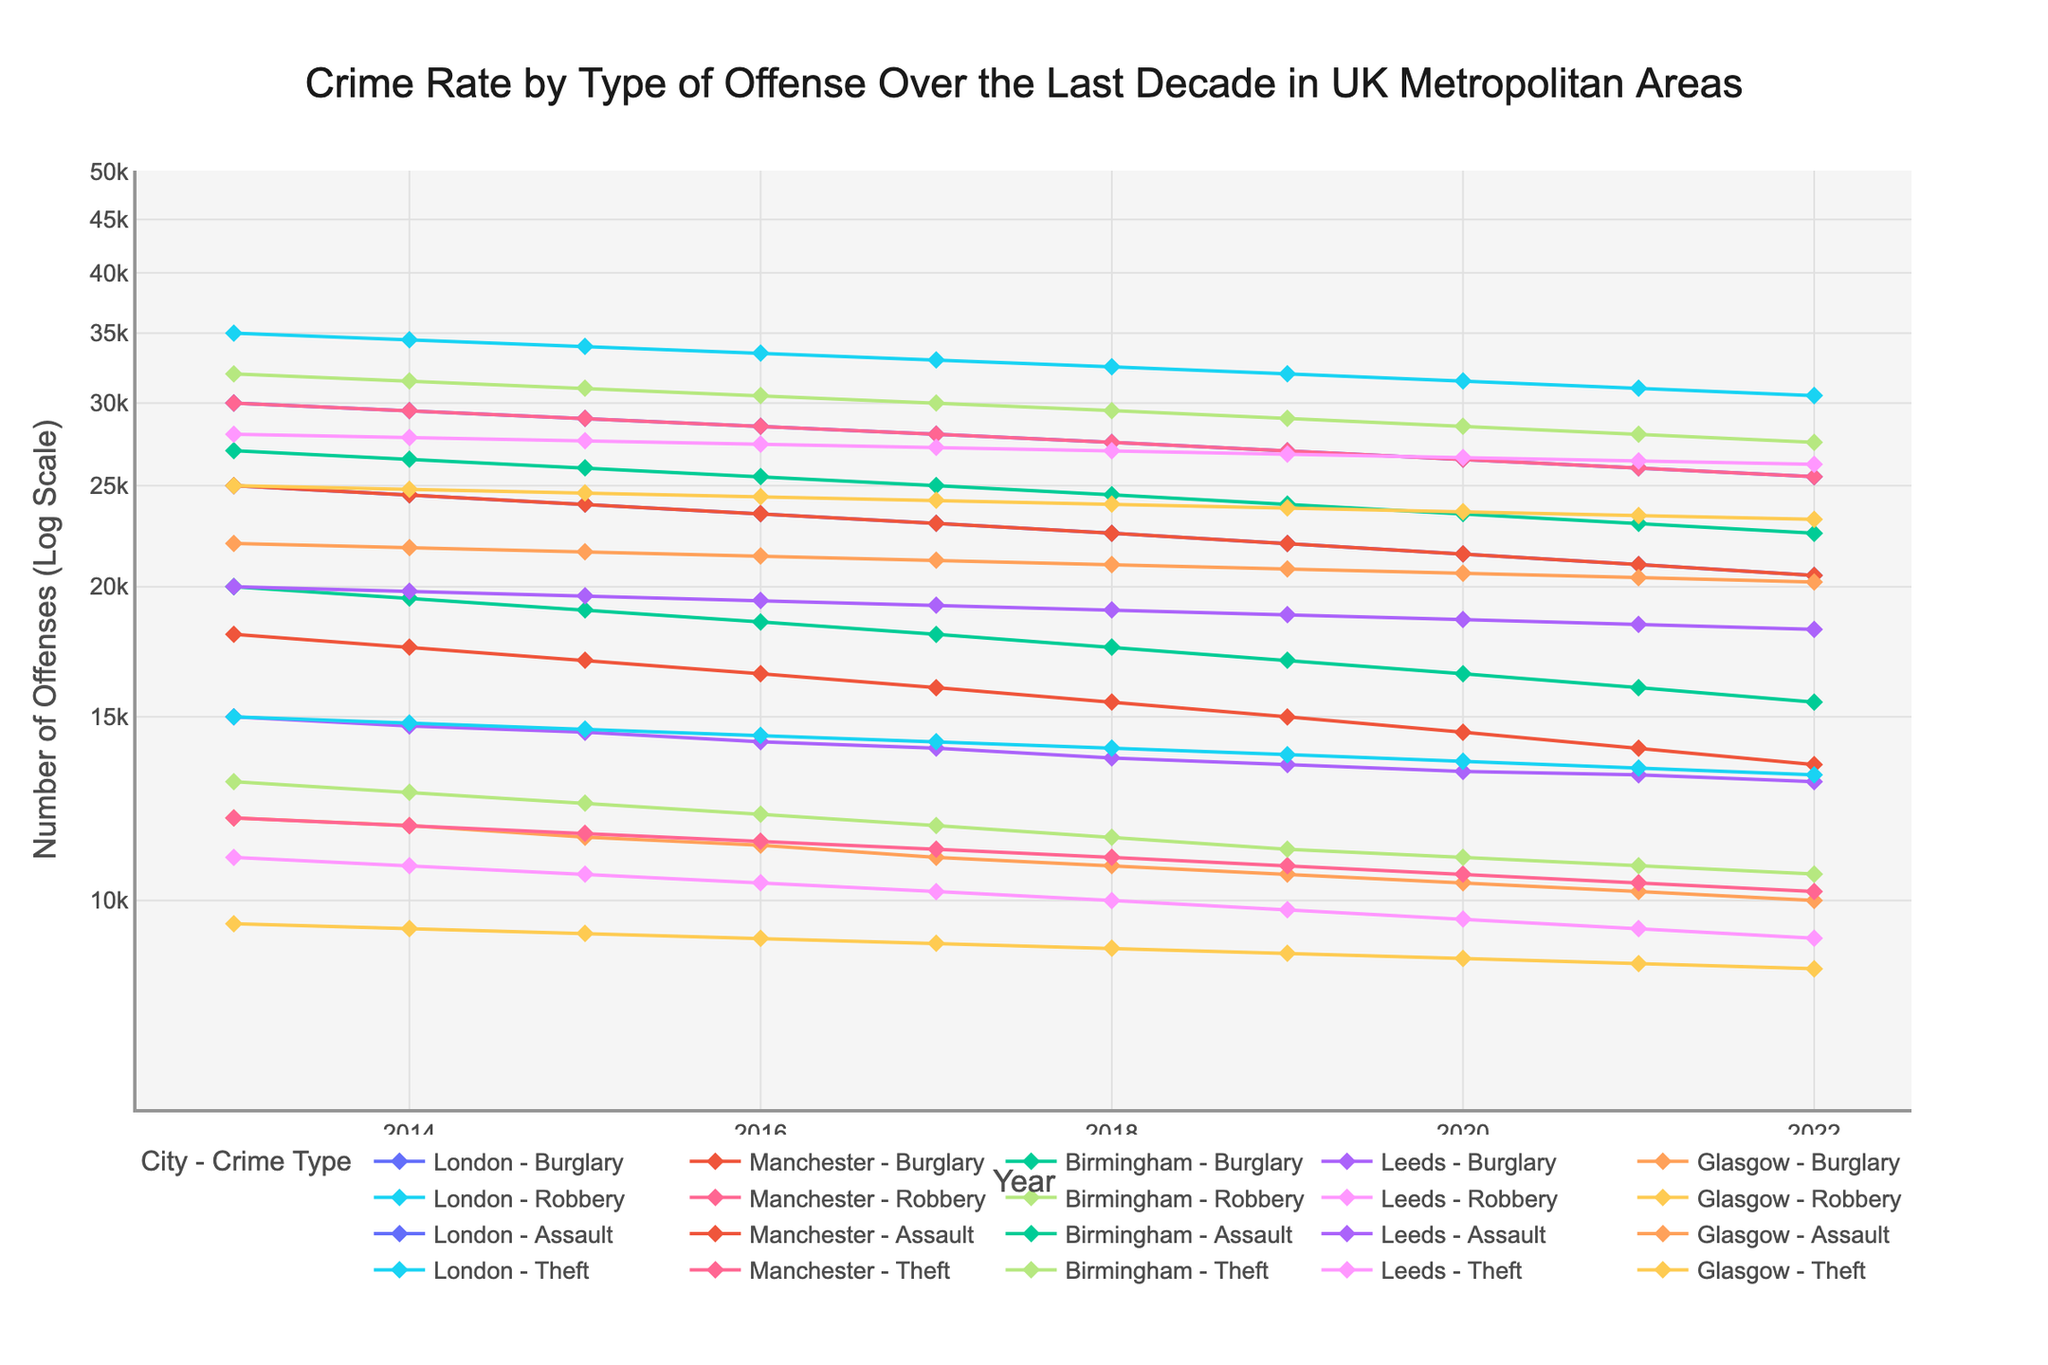what is the title of the figure? The title is usually displayed at the top of the figure. For this plot, it is clearly stated at the top and provides information about what the figure is about.
Answer: Crime Rate by Type of Offense Over the Last Decade in UK Metropolitan Areas what are the labels for the x-axis and y-axis? The labels are typically found along the corresponding axes. In this case, the x-axis label is found at the bottom and the y-axis label is found along the vertical side of the figure.
Answer: Year, Number of Offenses (Log Scale) which city had the highest number of burglaries in 2013? Look at the data points for the year 2013, then find the highest y-value corresponding to the 'Burglary' line for each city.
Answer: London how does the trend for assaults in Glasgow compare to Manchester over the decade? Compare the assault trend lines for Glasgow and Manchester by observing their slopes and overall direction over the entire time range.
Answer: Both decrease, but Glasgow slightly less steep which crime type showed the most consistent decrease over the years? Look at the overall trends for each crime type; the most consistent decrease will show a nearly straight line trending downwards without significant fluctuations.
Answer: Burglary what is the difference in the number of thefts between Leeds and Birmingham in 2020? Locate the data points for 'Theft' for both Leeds and Birmingham in year 2020, then subtract the smaller number from the larger number.
Answer: 200 which city saw the greatest decrease in robbery incidents from 2013 to 2022? Measure the vertical distance between the 'Robbery' data points for 2013 and 2022 in each city, and the city with the largest decrease will be the answer.
Answer: Manchester how does the log scale affect the perception of changes in crime rates? A log scale compresses larger values more than smaller values. Therefore, an increase or decrease will appear less drastic than on a linear scale, especially for larger values.
Answer: It makes changes appear less drastic in which year did Birmingham experience the lowest number of burglaries? Track the 'Burglary' line for Birmingham across all the years, then identify the year with the lowest data point.
Answer: 2022 